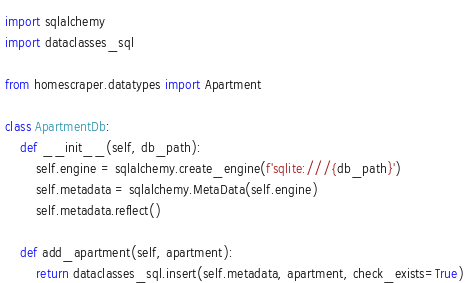<code> <loc_0><loc_0><loc_500><loc_500><_Python_>import sqlalchemy
import dataclasses_sql

from homescraper.datatypes import Apartment

class ApartmentDb:
    def __init__(self, db_path):
        self.engine = sqlalchemy.create_engine(f'sqlite:///{db_path}')
        self.metadata = sqlalchemy.MetaData(self.engine)
        self.metadata.reflect()

    def add_apartment(self, apartment):
        return dataclasses_sql.insert(self.metadata, apartment, check_exists=True)</code> 